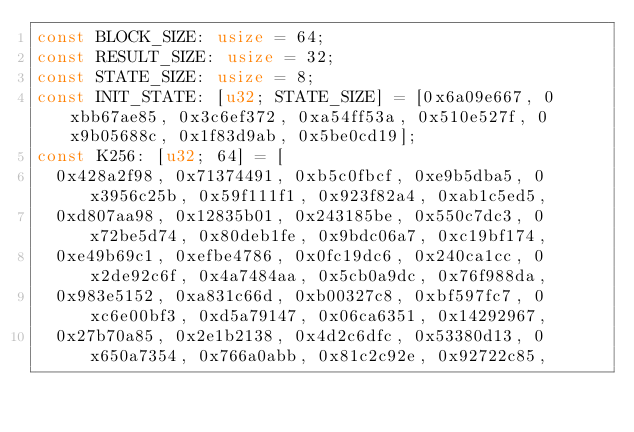<code> <loc_0><loc_0><loc_500><loc_500><_Rust_>const BLOCK_SIZE: usize = 64;
const RESULT_SIZE: usize = 32;
const STATE_SIZE: usize = 8;
const INIT_STATE: [u32; STATE_SIZE] = [0x6a09e667, 0xbb67ae85, 0x3c6ef372, 0xa54ff53a, 0x510e527f, 0x9b05688c, 0x1f83d9ab, 0x5be0cd19];
const K256: [u32; 64] = [
	0x428a2f98, 0x71374491, 0xb5c0fbcf, 0xe9b5dba5, 0x3956c25b, 0x59f111f1, 0x923f82a4, 0xab1c5ed5,
	0xd807aa98, 0x12835b01, 0x243185be, 0x550c7dc3, 0x72be5d74, 0x80deb1fe, 0x9bdc06a7, 0xc19bf174,
	0xe49b69c1, 0xefbe4786, 0x0fc19dc6, 0x240ca1cc, 0x2de92c6f, 0x4a7484aa, 0x5cb0a9dc, 0x76f988da,
	0x983e5152, 0xa831c66d, 0xb00327c8, 0xbf597fc7, 0xc6e00bf3, 0xd5a79147, 0x06ca6351, 0x14292967,
	0x27b70a85, 0x2e1b2138, 0x4d2c6dfc, 0x53380d13, 0x650a7354, 0x766a0abb, 0x81c2c92e, 0x92722c85,</code> 